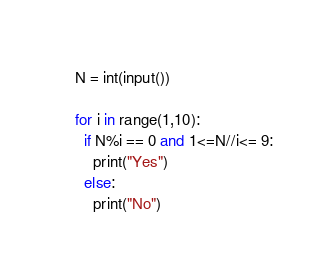<code> <loc_0><loc_0><loc_500><loc_500><_Python_>N = int(input())

for i in range(1,10):
  if N%i == 0 and 1<=N//i<= 9:
    print("Yes")
  else:
    print("No")</code> 